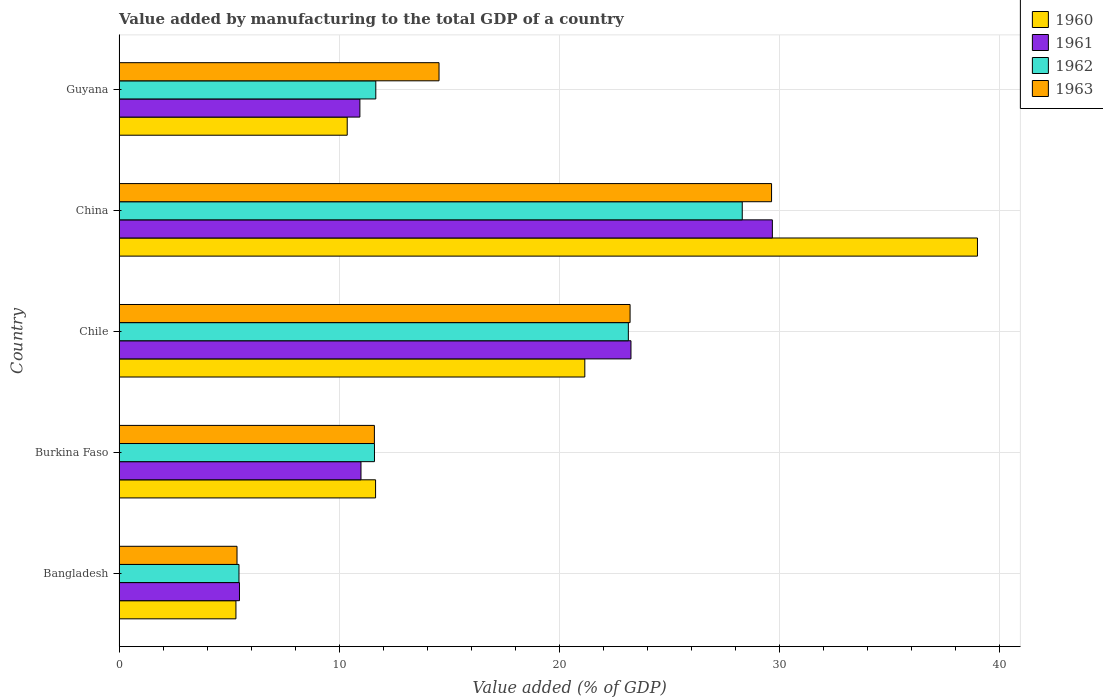How many different coloured bars are there?
Offer a very short reply. 4. How many groups of bars are there?
Offer a very short reply. 5. Are the number of bars on each tick of the Y-axis equal?
Make the answer very short. Yes. How many bars are there on the 2nd tick from the top?
Provide a succinct answer. 4. What is the label of the 4th group of bars from the top?
Your answer should be compact. Burkina Faso. What is the value added by manufacturing to the total GDP in 1963 in Bangladesh?
Keep it short and to the point. 5.36. Across all countries, what is the maximum value added by manufacturing to the total GDP in 1962?
Make the answer very short. 28.31. Across all countries, what is the minimum value added by manufacturing to the total GDP in 1962?
Provide a succinct answer. 5.45. In which country was the value added by manufacturing to the total GDP in 1962 maximum?
Make the answer very short. China. What is the total value added by manufacturing to the total GDP in 1961 in the graph?
Ensure brevity in your answer.  80.34. What is the difference between the value added by manufacturing to the total GDP in 1962 in Burkina Faso and that in Chile?
Offer a terse response. -11.53. What is the difference between the value added by manufacturing to the total GDP in 1962 in Burkina Faso and the value added by manufacturing to the total GDP in 1963 in China?
Provide a succinct answer. -18.04. What is the average value added by manufacturing to the total GDP in 1962 per country?
Offer a very short reply. 16.03. What is the difference between the value added by manufacturing to the total GDP in 1961 and value added by manufacturing to the total GDP in 1960 in Chile?
Your response must be concise. 2.1. What is the ratio of the value added by manufacturing to the total GDP in 1960 in Chile to that in China?
Give a very brief answer. 0.54. What is the difference between the highest and the second highest value added by manufacturing to the total GDP in 1962?
Give a very brief answer. 5.18. What is the difference between the highest and the lowest value added by manufacturing to the total GDP in 1961?
Keep it short and to the point. 24.21. Is it the case that in every country, the sum of the value added by manufacturing to the total GDP in 1960 and value added by manufacturing to the total GDP in 1962 is greater than the sum of value added by manufacturing to the total GDP in 1963 and value added by manufacturing to the total GDP in 1961?
Your response must be concise. No. What does the 4th bar from the bottom in Bangladesh represents?
Offer a terse response. 1963. How many countries are there in the graph?
Ensure brevity in your answer.  5. Does the graph contain grids?
Keep it short and to the point. Yes. Where does the legend appear in the graph?
Provide a succinct answer. Top right. What is the title of the graph?
Keep it short and to the point. Value added by manufacturing to the total GDP of a country. What is the label or title of the X-axis?
Offer a very short reply. Value added (% of GDP). What is the label or title of the Y-axis?
Your response must be concise. Country. What is the Value added (% of GDP) of 1960 in Bangladesh?
Give a very brief answer. 5.31. What is the Value added (% of GDP) in 1961 in Bangladesh?
Provide a succinct answer. 5.47. What is the Value added (% of GDP) in 1962 in Bangladesh?
Your answer should be compact. 5.45. What is the Value added (% of GDP) in 1963 in Bangladesh?
Your answer should be compact. 5.36. What is the Value added (% of GDP) of 1960 in Burkina Faso?
Give a very brief answer. 11.65. What is the Value added (% of GDP) of 1961 in Burkina Faso?
Offer a terse response. 10.99. What is the Value added (% of GDP) of 1962 in Burkina Faso?
Offer a very short reply. 11.6. What is the Value added (% of GDP) of 1963 in Burkina Faso?
Give a very brief answer. 11.6. What is the Value added (% of GDP) of 1960 in Chile?
Provide a succinct answer. 21.16. What is the Value added (% of GDP) of 1961 in Chile?
Ensure brevity in your answer.  23.26. What is the Value added (% of GDP) of 1962 in Chile?
Your answer should be compact. 23.14. What is the Value added (% of GDP) in 1963 in Chile?
Your answer should be very brief. 23.22. What is the Value added (% of GDP) in 1960 in China?
Your answer should be very brief. 39. What is the Value added (% of GDP) in 1961 in China?
Ensure brevity in your answer.  29.68. What is the Value added (% of GDP) of 1962 in China?
Make the answer very short. 28.31. What is the Value added (% of GDP) of 1963 in China?
Keep it short and to the point. 29.64. What is the Value added (% of GDP) of 1960 in Guyana?
Give a very brief answer. 10.37. What is the Value added (% of GDP) of 1961 in Guyana?
Offer a terse response. 10.94. What is the Value added (% of GDP) in 1962 in Guyana?
Offer a very short reply. 11.66. What is the Value added (% of GDP) in 1963 in Guyana?
Offer a terse response. 14.54. Across all countries, what is the maximum Value added (% of GDP) in 1960?
Give a very brief answer. 39. Across all countries, what is the maximum Value added (% of GDP) of 1961?
Give a very brief answer. 29.68. Across all countries, what is the maximum Value added (% of GDP) in 1962?
Keep it short and to the point. 28.31. Across all countries, what is the maximum Value added (% of GDP) in 1963?
Provide a short and direct response. 29.64. Across all countries, what is the minimum Value added (% of GDP) in 1960?
Offer a very short reply. 5.31. Across all countries, what is the minimum Value added (% of GDP) of 1961?
Ensure brevity in your answer.  5.47. Across all countries, what is the minimum Value added (% of GDP) of 1962?
Provide a short and direct response. 5.45. Across all countries, what is the minimum Value added (% of GDP) in 1963?
Your response must be concise. 5.36. What is the total Value added (% of GDP) of 1960 in the graph?
Give a very brief answer. 87.49. What is the total Value added (% of GDP) in 1961 in the graph?
Provide a short and direct response. 80.34. What is the total Value added (% of GDP) of 1962 in the graph?
Your answer should be very brief. 80.17. What is the total Value added (% of GDP) of 1963 in the graph?
Your answer should be very brief. 84.36. What is the difference between the Value added (% of GDP) of 1960 in Bangladesh and that in Burkina Faso?
Keep it short and to the point. -6.34. What is the difference between the Value added (% of GDP) in 1961 in Bangladesh and that in Burkina Faso?
Offer a very short reply. -5.52. What is the difference between the Value added (% of GDP) in 1962 in Bangladesh and that in Burkina Faso?
Make the answer very short. -6.16. What is the difference between the Value added (% of GDP) in 1963 in Bangladesh and that in Burkina Faso?
Your response must be concise. -6.24. What is the difference between the Value added (% of GDP) in 1960 in Bangladesh and that in Chile?
Provide a succinct answer. -15.85. What is the difference between the Value added (% of GDP) of 1961 in Bangladesh and that in Chile?
Make the answer very short. -17.79. What is the difference between the Value added (% of GDP) of 1962 in Bangladesh and that in Chile?
Give a very brief answer. -17.69. What is the difference between the Value added (% of GDP) of 1963 in Bangladesh and that in Chile?
Give a very brief answer. -17.86. What is the difference between the Value added (% of GDP) in 1960 in Bangladesh and that in China?
Offer a terse response. -33.69. What is the difference between the Value added (% of GDP) in 1961 in Bangladesh and that in China?
Ensure brevity in your answer.  -24.21. What is the difference between the Value added (% of GDP) in 1962 in Bangladesh and that in China?
Provide a succinct answer. -22.86. What is the difference between the Value added (% of GDP) of 1963 in Bangladesh and that in China?
Offer a very short reply. -24.28. What is the difference between the Value added (% of GDP) of 1960 in Bangladesh and that in Guyana?
Give a very brief answer. -5.06. What is the difference between the Value added (% of GDP) of 1961 in Bangladesh and that in Guyana?
Your answer should be very brief. -5.47. What is the difference between the Value added (% of GDP) of 1962 in Bangladesh and that in Guyana?
Your answer should be compact. -6.22. What is the difference between the Value added (% of GDP) in 1963 in Bangladesh and that in Guyana?
Your response must be concise. -9.18. What is the difference between the Value added (% of GDP) in 1960 in Burkina Faso and that in Chile?
Offer a very short reply. -9.51. What is the difference between the Value added (% of GDP) of 1961 in Burkina Faso and that in Chile?
Your answer should be very brief. -12.27. What is the difference between the Value added (% of GDP) of 1962 in Burkina Faso and that in Chile?
Offer a terse response. -11.53. What is the difference between the Value added (% of GDP) of 1963 in Burkina Faso and that in Chile?
Provide a short and direct response. -11.62. What is the difference between the Value added (% of GDP) in 1960 in Burkina Faso and that in China?
Ensure brevity in your answer.  -27.34. What is the difference between the Value added (% of GDP) in 1961 in Burkina Faso and that in China?
Your answer should be compact. -18.69. What is the difference between the Value added (% of GDP) in 1962 in Burkina Faso and that in China?
Keep it short and to the point. -16.71. What is the difference between the Value added (% of GDP) in 1963 in Burkina Faso and that in China?
Keep it short and to the point. -18.04. What is the difference between the Value added (% of GDP) in 1960 in Burkina Faso and that in Guyana?
Ensure brevity in your answer.  1.29. What is the difference between the Value added (% of GDP) of 1961 in Burkina Faso and that in Guyana?
Provide a succinct answer. 0.05. What is the difference between the Value added (% of GDP) of 1962 in Burkina Faso and that in Guyana?
Provide a short and direct response. -0.06. What is the difference between the Value added (% of GDP) of 1963 in Burkina Faso and that in Guyana?
Provide a short and direct response. -2.94. What is the difference between the Value added (% of GDP) of 1960 in Chile and that in China?
Offer a terse response. -17.84. What is the difference between the Value added (% of GDP) of 1961 in Chile and that in China?
Make the answer very short. -6.42. What is the difference between the Value added (% of GDP) in 1962 in Chile and that in China?
Make the answer very short. -5.17. What is the difference between the Value added (% of GDP) of 1963 in Chile and that in China?
Provide a short and direct response. -6.43. What is the difference between the Value added (% of GDP) in 1960 in Chile and that in Guyana?
Your answer should be compact. 10.79. What is the difference between the Value added (% of GDP) of 1961 in Chile and that in Guyana?
Make the answer very short. 12.32. What is the difference between the Value added (% of GDP) of 1962 in Chile and that in Guyana?
Offer a very short reply. 11.47. What is the difference between the Value added (% of GDP) of 1963 in Chile and that in Guyana?
Provide a short and direct response. 8.68. What is the difference between the Value added (% of GDP) of 1960 in China and that in Guyana?
Provide a short and direct response. 28.63. What is the difference between the Value added (% of GDP) in 1961 in China and that in Guyana?
Your answer should be very brief. 18.74. What is the difference between the Value added (% of GDP) in 1962 in China and that in Guyana?
Your answer should be very brief. 16.65. What is the difference between the Value added (% of GDP) in 1963 in China and that in Guyana?
Provide a succinct answer. 15.11. What is the difference between the Value added (% of GDP) in 1960 in Bangladesh and the Value added (% of GDP) in 1961 in Burkina Faso?
Ensure brevity in your answer.  -5.68. What is the difference between the Value added (% of GDP) of 1960 in Bangladesh and the Value added (% of GDP) of 1962 in Burkina Faso?
Offer a terse response. -6.29. What is the difference between the Value added (% of GDP) of 1960 in Bangladesh and the Value added (% of GDP) of 1963 in Burkina Faso?
Offer a terse response. -6.29. What is the difference between the Value added (% of GDP) in 1961 in Bangladesh and the Value added (% of GDP) in 1962 in Burkina Faso?
Give a very brief answer. -6.13. What is the difference between the Value added (% of GDP) of 1961 in Bangladesh and the Value added (% of GDP) of 1963 in Burkina Faso?
Keep it short and to the point. -6.13. What is the difference between the Value added (% of GDP) of 1962 in Bangladesh and the Value added (% of GDP) of 1963 in Burkina Faso?
Make the answer very short. -6.15. What is the difference between the Value added (% of GDP) of 1960 in Bangladesh and the Value added (% of GDP) of 1961 in Chile?
Provide a short and direct response. -17.95. What is the difference between the Value added (% of GDP) in 1960 in Bangladesh and the Value added (% of GDP) in 1962 in Chile?
Keep it short and to the point. -17.83. What is the difference between the Value added (% of GDP) of 1960 in Bangladesh and the Value added (% of GDP) of 1963 in Chile?
Provide a succinct answer. -17.91. What is the difference between the Value added (% of GDP) of 1961 in Bangladesh and the Value added (% of GDP) of 1962 in Chile?
Offer a terse response. -17.67. What is the difference between the Value added (% of GDP) of 1961 in Bangladesh and the Value added (% of GDP) of 1963 in Chile?
Your answer should be very brief. -17.75. What is the difference between the Value added (% of GDP) of 1962 in Bangladesh and the Value added (% of GDP) of 1963 in Chile?
Your answer should be compact. -17.77. What is the difference between the Value added (% of GDP) of 1960 in Bangladesh and the Value added (% of GDP) of 1961 in China?
Keep it short and to the point. -24.37. What is the difference between the Value added (% of GDP) in 1960 in Bangladesh and the Value added (% of GDP) in 1962 in China?
Keep it short and to the point. -23. What is the difference between the Value added (% of GDP) of 1960 in Bangladesh and the Value added (% of GDP) of 1963 in China?
Your response must be concise. -24.33. What is the difference between the Value added (% of GDP) of 1961 in Bangladesh and the Value added (% of GDP) of 1962 in China?
Keep it short and to the point. -22.84. What is the difference between the Value added (% of GDP) of 1961 in Bangladesh and the Value added (% of GDP) of 1963 in China?
Give a very brief answer. -24.17. What is the difference between the Value added (% of GDP) of 1962 in Bangladesh and the Value added (% of GDP) of 1963 in China?
Ensure brevity in your answer.  -24.2. What is the difference between the Value added (% of GDP) of 1960 in Bangladesh and the Value added (% of GDP) of 1961 in Guyana?
Make the answer very short. -5.63. What is the difference between the Value added (% of GDP) in 1960 in Bangladesh and the Value added (% of GDP) in 1962 in Guyana?
Offer a very short reply. -6.35. What is the difference between the Value added (% of GDP) of 1960 in Bangladesh and the Value added (% of GDP) of 1963 in Guyana?
Your answer should be compact. -9.23. What is the difference between the Value added (% of GDP) in 1961 in Bangladesh and the Value added (% of GDP) in 1962 in Guyana?
Offer a very short reply. -6.19. What is the difference between the Value added (% of GDP) of 1961 in Bangladesh and the Value added (% of GDP) of 1963 in Guyana?
Give a very brief answer. -9.07. What is the difference between the Value added (% of GDP) in 1962 in Bangladesh and the Value added (% of GDP) in 1963 in Guyana?
Ensure brevity in your answer.  -9.09. What is the difference between the Value added (% of GDP) in 1960 in Burkina Faso and the Value added (% of GDP) in 1961 in Chile?
Provide a short and direct response. -11.6. What is the difference between the Value added (% of GDP) of 1960 in Burkina Faso and the Value added (% of GDP) of 1962 in Chile?
Your answer should be very brief. -11.48. What is the difference between the Value added (% of GDP) in 1960 in Burkina Faso and the Value added (% of GDP) in 1963 in Chile?
Your response must be concise. -11.56. What is the difference between the Value added (% of GDP) of 1961 in Burkina Faso and the Value added (% of GDP) of 1962 in Chile?
Offer a terse response. -12.15. What is the difference between the Value added (% of GDP) of 1961 in Burkina Faso and the Value added (% of GDP) of 1963 in Chile?
Ensure brevity in your answer.  -12.23. What is the difference between the Value added (% of GDP) of 1962 in Burkina Faso and the Value added (% of GDP) of 1963 in Chile?
Offer a very short reply. -11.61. What is the difference between the Value added (% of GDP) in 1960 in Burkina Faso and the Value added (% of GDP) in 1961 in China?
Provide a short and direct response. -18.03. What is the difference between the Value added (% of GDP) of 1960 in Burkina Faso and the Value added (% of GDP) of 1962 in China?
Your response must be concise. -16.66. What is the difference between the Value added (% of GDP) of 1960 in Burkina Faso and the Value added (% of GDP) of 1963 in China?
Offer a very short reply. -17.99. What is the difference between the Value added (% of GDP) in 1961 in Burkina Faso and the Value added (% of GDP) in 1962 in China?
Offer a very short reply. -17.32. What is the difference between the Value added (% of GDP) of 1961 in Burkina Faso and the Value added (% of GDP) of 1963 in China?
Keep it short and to the point. -18.65. What is the difference between the Value added (% of GDP) of 1962 in Burkina Faso and the Value added (% of GDP) of 1963 in China?
Make the answer very short. -18.04. What is the difference between the Value added (% of GDP) in 1960 in Burkina Faso and the Value added (% of GDP) in 1961 in Guyana?
Your answer should be compact. 0.71. What is the difference between the Value added (% of GDP) of 1960 in Burkina Faso and the Value added (% of GDP) of 1962 in Guyana?
Your response must be concise. -0.01. What is the difference between the Value added (% of GDP) of 1960 in Burkina Faso and the Value added (% of GDP) of 1963 in Guyana?
Your response must be concise. -2.88. What is the difference between the Value added (% of GDP) of 1961 in Burkina Faso and the Value added (% of GDP) of 1962 in Guyana?
Offer a very short reply. -0.67. What is the difference between the Value added (% of GDP) in 1961 in Burkina Faso and the Value added (% of GDP) in 1963 in Guyana?
Give a very brief answer. -3.55. What is the difference between the Value added (% of GDP) in 1962 in Burkina Faso and the Value added (% of GDP) in 1963 in Guyana?
Offer a terse response. -2.93. What is the difference between the Value added (% of GDP) of 1960 in Chile and the Value added (% of GDP) of 1961 in China?
Provide a succinct answer. -8.52. What is the difference between the Value added (% of GDP) of 1960 in Chile and the Value added (% of GDP) of 1962 in China?
Offer a very short reply. -7.15. What is the difference between the Value added (% of GDP) of 1960 in Chile and the Value added (% of GDP) of 1963 in China?
Keep it short and to the point. -8.48. What is the difference between the Value added (% of GDP) in 1961 in Chile and the Value added (% of GDP) in 1962 in China?
Give a very brief answer. -5.06. What is the difference between the Value added (% of GDP) of 1961 in Chile and the Value added (% of GDP) of 1963 in China?
Make the answer very short. -6.39. What is the difference between the Value added (% of GDP) of 1962 in Chile and the Value added (% of GDP) of 1963 in China?
Provide a short and direct response. -6.51. What is the difference between the Value added (% of GDP) in 1960 in Chile and the Value added (% of GDP) in 1961 in Guyana?
Your answer should be compact. 10.22. What is the difference between the Value added (% of GDP) of 1960 in Chile and the Value added (% of GDP) of 1962 in Guyana?
Give a very brief answer. 9.5. What is the difference between the Value added (% of GDP) in 1960 in Chile and the Value added (% of GDP) in 1963 in Guyana?
Your answer should be very brief. 6.62. What is the difference between the Value added (% of GDP) of 1961 in Chile and the Value added (% of GDP) of 1962 in Guyana?
Provide a short and direct response. 11.59. What is the difference between the Value added (% of GDP) of 1961 in Chile and the Value added (% of GDP) of 1963 in Guyana?
Your answer should be very brief. 8.72. What is the difference between the Value added (% of GDP) in 1962 in Chile and the Value added (% of GDP) in 1963 in Guyana?
Offer a terse response. 8.6. What is the difference between the Value added (% of GDP) of 1960 in China and the Value added (% of GDP) of 1961 in Guyana?
Keep it short and to the point. 28.06. What is the difference between the Value added (% of GDP) of 1960 in China and the Value added (% of GDP) of 1962 in Guyana?
Your answer should be compact. 27.33. What is the difference between the Value added (% of GDP) of 1960 in China and the Value added (% of GDP) of 1963 in Guyana?
Offer a very short reply. 24.46. What is the difference between the Value added (% of GDP) in 1961 in China and the Value added (% of GDP) in 1962 in Guyana?
Your answer should be very brief. 18.02. What is the difference between the Value added (% of GDP) in 1961 in China and the Value added (% of GDP) in 1963 in Guyana?
Your answer should be very brief. 15.14. What is the difference between the Value added (% of GDP) in 1962 in China and the Value added (% of GDP) in 1963 in Guyana?
Offer a very short reply. 13.78. What is the average Value added (% of GDP) of 1960 per country?
Offer a very short reply. 17.5. What is the average Value added (% of GDP) of 1961 per country?
Offer a terse response. 16.07. What is the average Value added (% of GDP) of 1962 per country?
Your answer should be compact. 16.03. What is the average Value added (% of GDP) of 1963 per country?
Give a very brief answer. 16.87. What is the difference between the Value added (% of GDP) in 1960 and Value added (% of GDP) in 1961 in Bangladesh?
Your response must be concise. -0.16. What is the difference between the Value added (% of GDP) of 1960 and Value added (% of GDP) of 1962 in Bangladesh?
Provide a short and direct response. -0.14. What is the difference between the Value added (% of GDP) of 1960 and Value added (% of GDP) of 1963 in Bangladesh?
Give a very brief answer. -0.05. What is the difference between the Value added (% of GDP) of 1961 and Value added (% of GDP) of 1962 in Bangladesh?
Your response must be concise. 0.02. What is the difference between the Value added (% of GDP) in 1961 and Value added (% of GDP) in 1963 in Bangladesh?
Provide a short and direct response. 0.11. What is the difference between the Value added (% of GDP) of 1962 and Value added (% of GDP) of 1963 in Bangladesh?
Keep it short and to the point. 0.09. What is the difference between the Value added (% of GDP) in 1960 and Value added (% of GDP) in 1961 in Burkina Faso?
Your response must be concise. 0.66. What is the difference between the Value added (% of GDP) of 1960 and Value added (% of GDP) of 1962 in Burkina Faso?
Give a very brief answer. 0.05. What is the difference between the Value added (% of GDP) of 1960 and Value added (% of GDP) of 1963 in Burkina Faso?
Your response must be concise. 0.05. What is the difference between the Value added (% of GDP) in 1961 and Value added (% of GDP) in 1962 in Burkina Faso?
Keep it short and to the point. -0.61. What is the difference between the Value added (% of GDP) in 1961 and Value added (% of GDP) in 1963 in Burkina Faso?
Provide a succinct answer. -0.61. What is the difference between the Value added (% of GDP) of 1962 and Value added (% of GDP) of 1963 in Burkina Faso?
Provide a short and direct response. 0. What is the difference between the Value added (% of GDP) in 1960 and Value added (% of GDP) in 1961 in Chile?
Offer a very short reply. -2.1. What is the difference between the Value added (% of GDP) of 1960 and Value added (% of GDP) of 1962 in Chile?
Provide a succinct answer. -1.98. What is the difference between the Value added (% of GDP) of 1960 and Value added (% of GDP) of 1963 in Chile?
Your answer should be compact. -2.06. What is the difference between the Value added (% of GDP) of 1961 and Value added (% of GDP) of 1962 in Chile?
Provide a succinct answer. 0.12. What is the difference between the Value added (% of GDP) of 1961 and Value added (% of GDP) of 1963 in Chile?
Your answer should be very brief. 0.04. What is the difference between the Value added (% of GDP) in 1962 and Value added (% of GDP) in 1963 in Chile?
Your answer should be very brief. -0.08. What is the difference between the Value added (% of GDP) of 1960 and Value added (% of GDP) of 1961 in China?
Ensure brevity in your answer.  9.32. What is the difference between the Value added (% of GDP) in 1960 and Value added (% of GDP) in 1962 in China?
Give a very brief answer. 10.69. What is the difference between the Value added (% of GDP) of 1960 and Value added (% of GDP) of 1963 in China?
Keep it short and to the point. 9.35. What is the difference between the Value added (% of GDP) in 1961 and Value added (% of GDP) in 1962 in China?
Offer a terse response. 1.37. What is the difference between the Value added (% of GDP) of 1961 and Value added (% of GDP) of 1963 in China?
Provide a short and direct response. 0.04. What is the difference between the Value added (% of GDP) of 1962 and Value added (% of GDP) of 1963 in China?
Your answer should be very brief. -1.33. What is the difference between the Value added (% of GDP) in 1960 and Value added (% of GDP) in 1961 in Guyana?
Ensure brevity in your answer.  -0.58. What is the difference between the Value added (% of GDP) of 1960 and Value added (% of GDP) of 1962 in Guyana?
Offer a terse response. -1.3. What is the difference between the Value added (% of GDP) in 1960 and Value added (% of GDP) in 1963 in Guyana?
Offer a very short reply. -4.17. What is the difference between the Value added (% of GDP) in 1961 and Value added (% of GDP) in 1962 in Guyana?
Make the answer very short. -0.72. What is the difference between the Value added (% of GDP) of 1961 and Value added (% of GDP) of 1963 in Guyana?
Your answer should be compact. -3.6. What is the difference between the Value added (% of GDP) of 1962 and Value added (% of GDP) of 1963 in Guyana?
Offer a terse response. -2.87. What is the ratio of the Value added (% of GDP) of 1960 in Bangladesh to that in Burkina Faso?
Provide a succinct answer. 0.46. What is the ratio of the Value added (% of GDP) of 1961 in Bangladesh to that in Burkina Faso?
Make the answer very short. 0.5. What is the ratio of the Value added (% of GDP) in 1962 in Bangladesh to that in Burkina Faso?
Offer a very short reply. 0.47. What is the ratio of the Value added (% of GDP) of 1963 in Bangladesh to that in Burkina Faso?
Offer a terse response. 0.46. What is the ratio of the Value added (% of GDP) of 1960 in Bangladesh to that in Chile?
Your answer should be compact. 0.25. What is the ratio of the Value added (% of GDP) of 1961 in Bangladesh to that in Chile?
Your answer should be very brief. 0.24. What is the ratio of the Value added (% of GDP) of 1962 in Bangladesh to that in Chile?
Provide a succinct answer. 0.24. What is the ratio of the Value added (% of GDP) in 1963 in Bangladesh to that in Chile?
Your response must be concise. 0.23. What is the ratio of the Value added (% of GDP) of 1960 in Bangladesh to that in China?
Give a very brief answer. 0.14. What is the ratio of the Value added (% of GDP) in 1961 in Bangladesh to that in China?
Provide a short and direct response. 0.18. What is the ratio of the Value added (% of GDP) of 1962 in Bangladesh to that in China?
Your answer should be compact. 0.19. What is the ratio of the Value added (% of GDP) of 1963 in Bangladesh to that in China?
Provide a succinct answer. 0.18. What is the ratio of the Value added (% of GDP) of 1960 in Bangladesh to that in Guyana?
Offer a very short reply. 0.51. What is the ratio of the Value added (% of GDP) in 1962 in Bangladesh to that in Guyana?
Your answer should be very brief. 0.47. What is the ratio of the Value added (% of GDP) of 1963 in Bangladesh to that in Guyana?
Your answer should be very brief. 0.37. What is the ratio of the Value added (% of GDP) in 1960 in Burkina Faso to that in Chile?
Your answer should be compact. 0.55. What is the ratio of the Value added (% of GDP) of 1961 in Burkina Faso to that in Chile?
Offer a very short reply. 0.47. What is the ratio of the Value added (% of GDP) in 1962 in Burkina Faso to that in Chile?
Ensure brevity in your answer.  0.5. What is the ratio of the Value added (% of GDP) in 1963 in Burkina Faso to that in Chile?
Your answer should be compact. 0.5. What is the ratio of the Value added (% of GDP) of 1960 in Burkina Faso to that in China?
Your answer should be compact. 0.3. What is the ratio of the Value added (% of GDP) of 1961 in Burkina Faso to that in China?
Keep it short and to the point. 0.37. What is the ratio of the Value added (% of GDP) of 1962 in Burkina Faso to that in China?
Provide a short and direct response. 0.41. What is the ratio of the Value added (% of GDP) in 1963 in Burkina Faso to that in China?
Provide a succinct answer. 0.39. What is the ratio of the Value added (% of GDP) in 1960 in Burkina Faso to that in Guyana?
Offer a terse response. 1.12. What is the ratio of the Value added (% of GDP) in 1961 in Burkina Faso to that in Guyana?
Your response must be concise. 1. What is the ratio of the Value added (% of GDP) in 1962 in Burkina Faso to that in Guyana?
Provide a succinct answer. 0.99. What is the ratio of the Value added (% of GDP) in 1963 in Burkina Faso to that in Guyana?
Ensure brevity in your answer.  0.8. What is the ratio of the Value added (% of GDP) of 1960 in Chile to that in China?
Make the answer very short. 0.54. What is the ratio of the Value added (% of GDP) of 1961 in Chile to that in China?
Offer a terse response. 0.78. What is the ratio of the Value added (% of GDP) in 1962 in Chile to that in China?
Ensure brevity in your answer.  0.82. What is the ratio of the Value added (% of GDP) of 1963 in Chile to that in China?
Ensure brevity in your answer.  0.78. What is the ratio of the Value added (% of GDP) in 1960 in Chile to that in Guyana?
Keep it short and to the point. 2.04. What is the ratio of the Value added (% of GDP) of 1961 in Chile to that in Guyana?
Provide a short and direct response. 2.13. What is the ratio of the Value added (% of GDP) in 1962 in Chile to that in Guyana?
Make the answer very short. 1.98. What is the ratio of the Value added (% of GDP) of 1963 in Chile to that in Guyana?
Ensure brevity in your answer.  1.6. What is the ratio of the Value added (% of GDP) of 1960 in China to that in Guyana?
Ensure brevity in your answer.  3.76. What is the ratio of the Value added (% of GDP) in 1961 in China to that in Guyana?
Your answer should be very brief. 2.71. What is the ratio of the Value added (% of GDP) in 1962 in China to that in Guyana?
Offer a very short reply. 2.43. What is the ratio of the Value added (% of GDP) in 1963 in China to that in Guyana?
Offer a terse response. 2.04. What is the difference between the highest and the second highest Value added (% of GDP) in 1960?
Provide a short and direct response. 17.84. What is the difference between the highest and the second highest Value added (% of GDP) in 1961?
Give a very brief answer. 6.42. What is the difference between the highest and the second highest Value added (% of GDP) in 1962?
Your answer should be very brief. 5.17. What is the difference between the highest and the second highest Value added (% of GDP) in 1963?
Your answer should be compact. 6.43. What is the difference between the highest and the lowest Value added (% of GDP) in 1960?
Ensure brevity in your answer.  33.69. What is the difference between the highest and the lowest Value added (% of GDP) in 1961?
Offer a very short reply. 24.21. What is the difference between the highest and the lowest Value added (% of GDP) of 1962?
Your response must be concise. 22.86. What is the difference between the highest and the lowest Value added (% of GDP) of 1963?
Give a very brief answer. 24.28. 